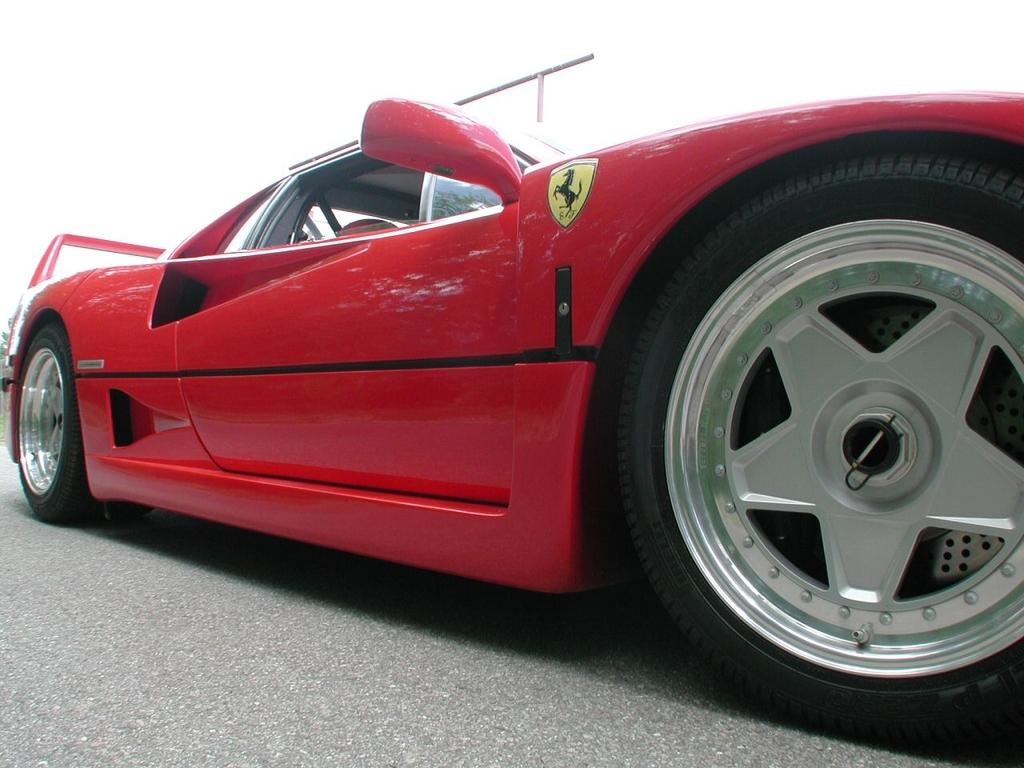What color is the car in the image? The car in the image is red. Where is the car located in the image? The car is on the road in the image. What can be seen on the car? There is a logo on the car. What is visible in the background of the image? The sky is visible in the background of the image. Can you see a stone pig at the party in the image? There is no party or stone pig present in the image; it features a red car on the road with a visible sky in the background. 